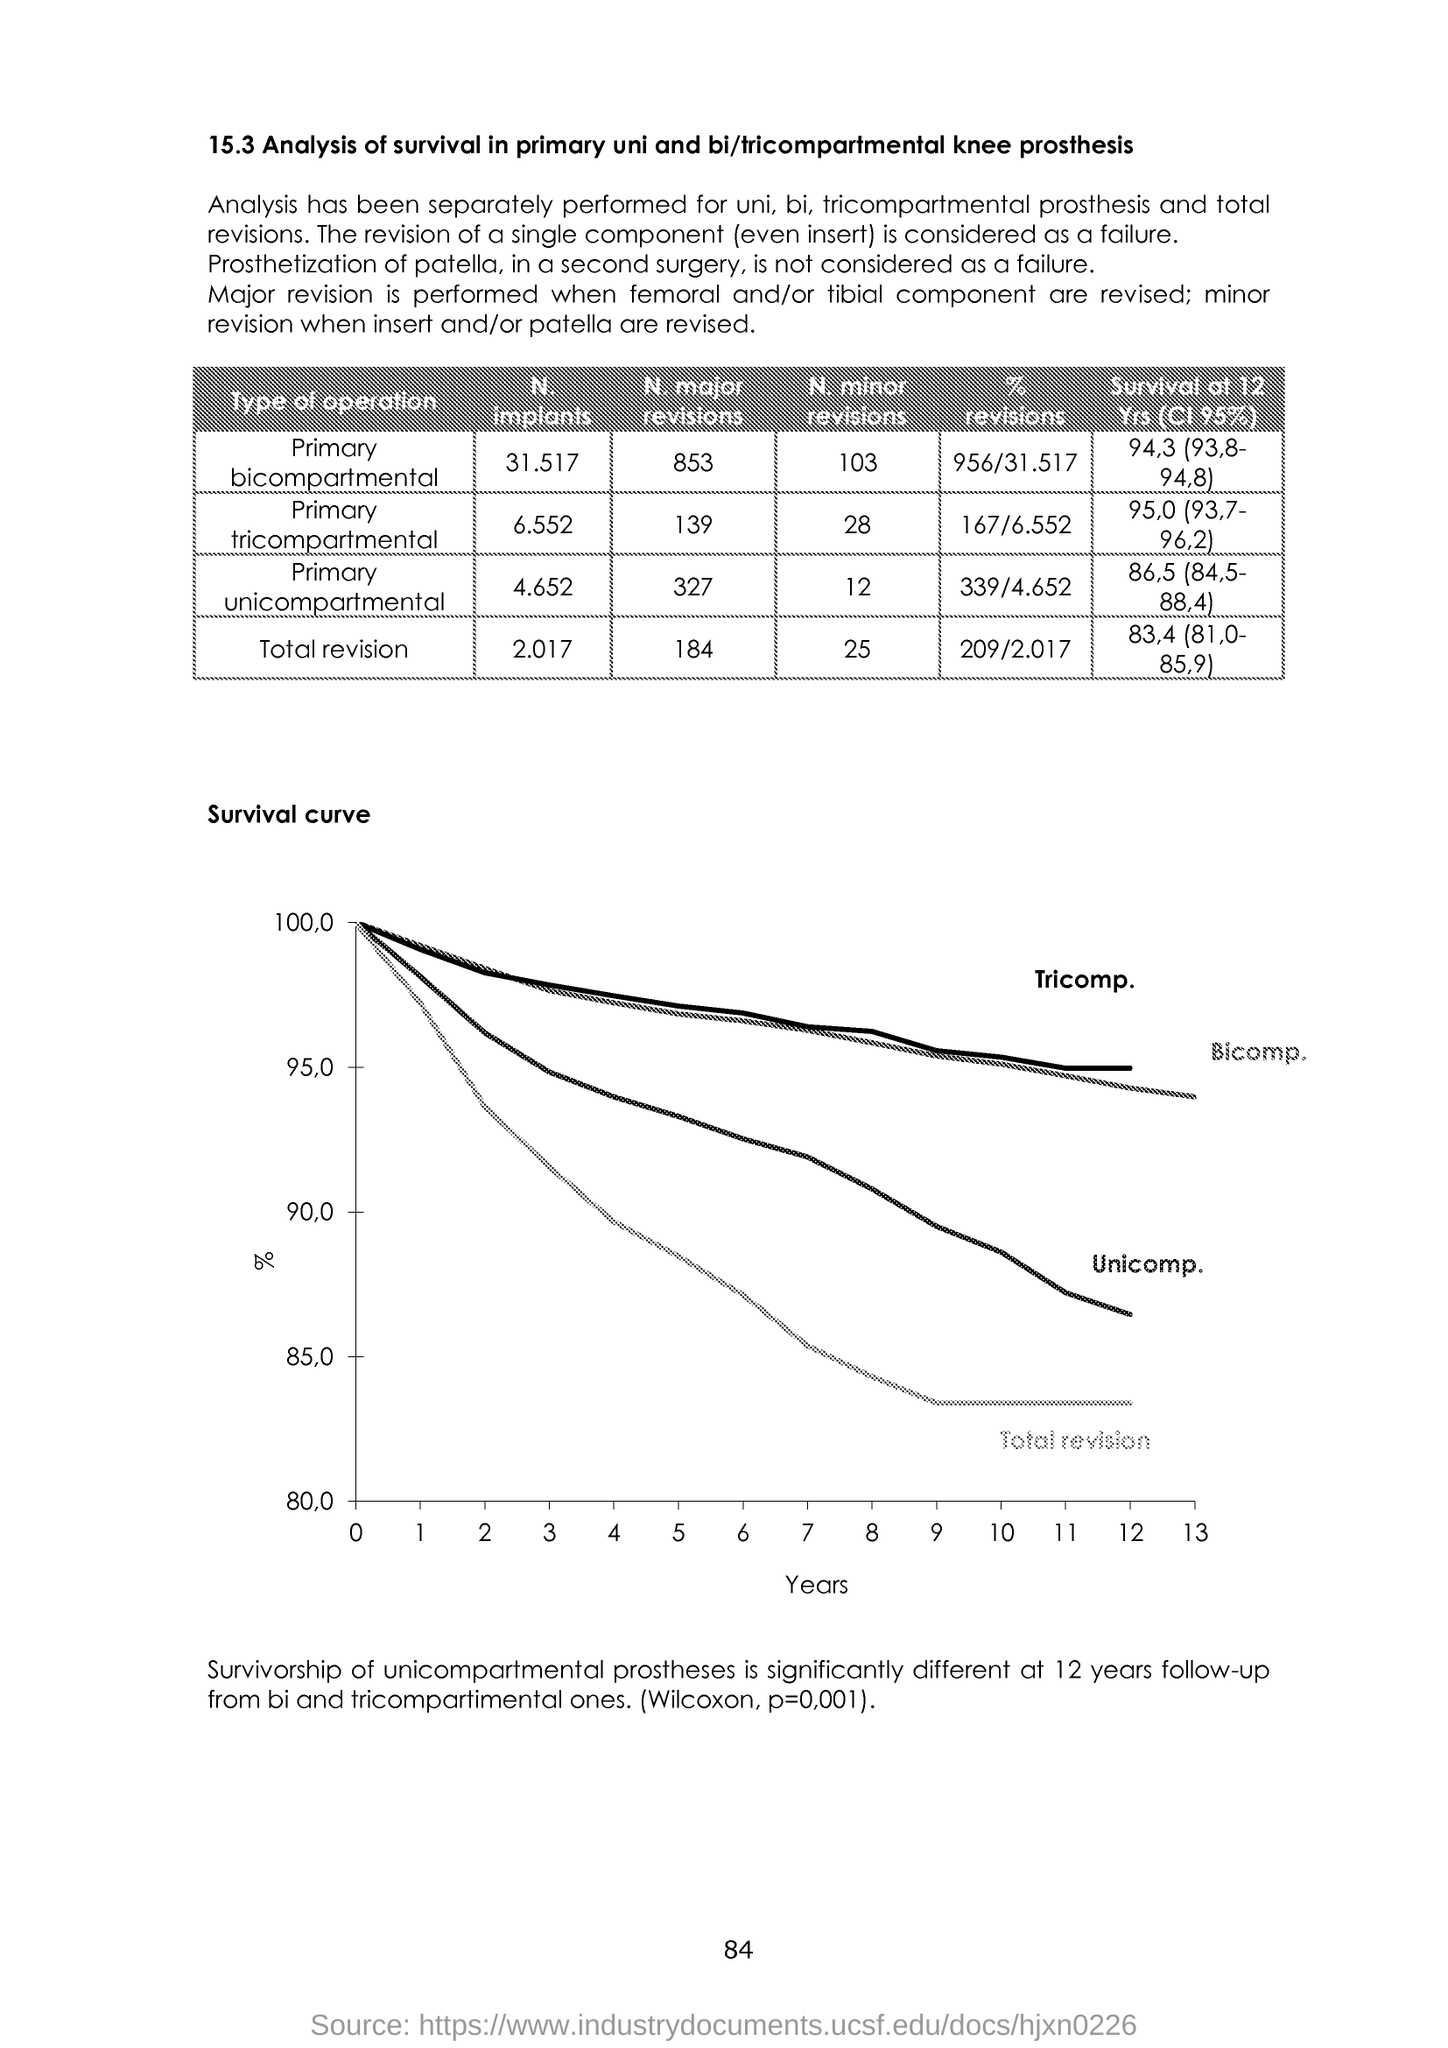What is plotted in the x-axis ?
 years 